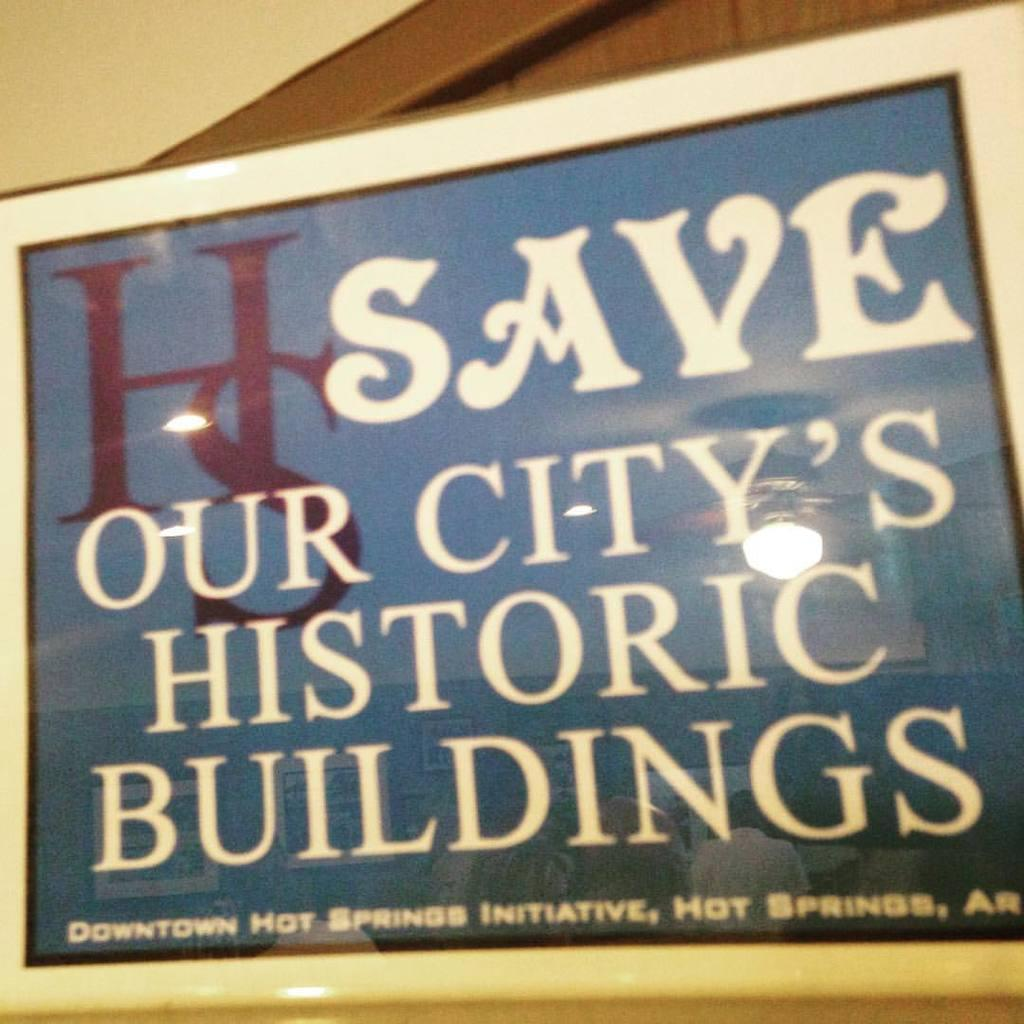<image>
Describe the image concisely. A blue and white sign urges people to save the city's historic buildings. 